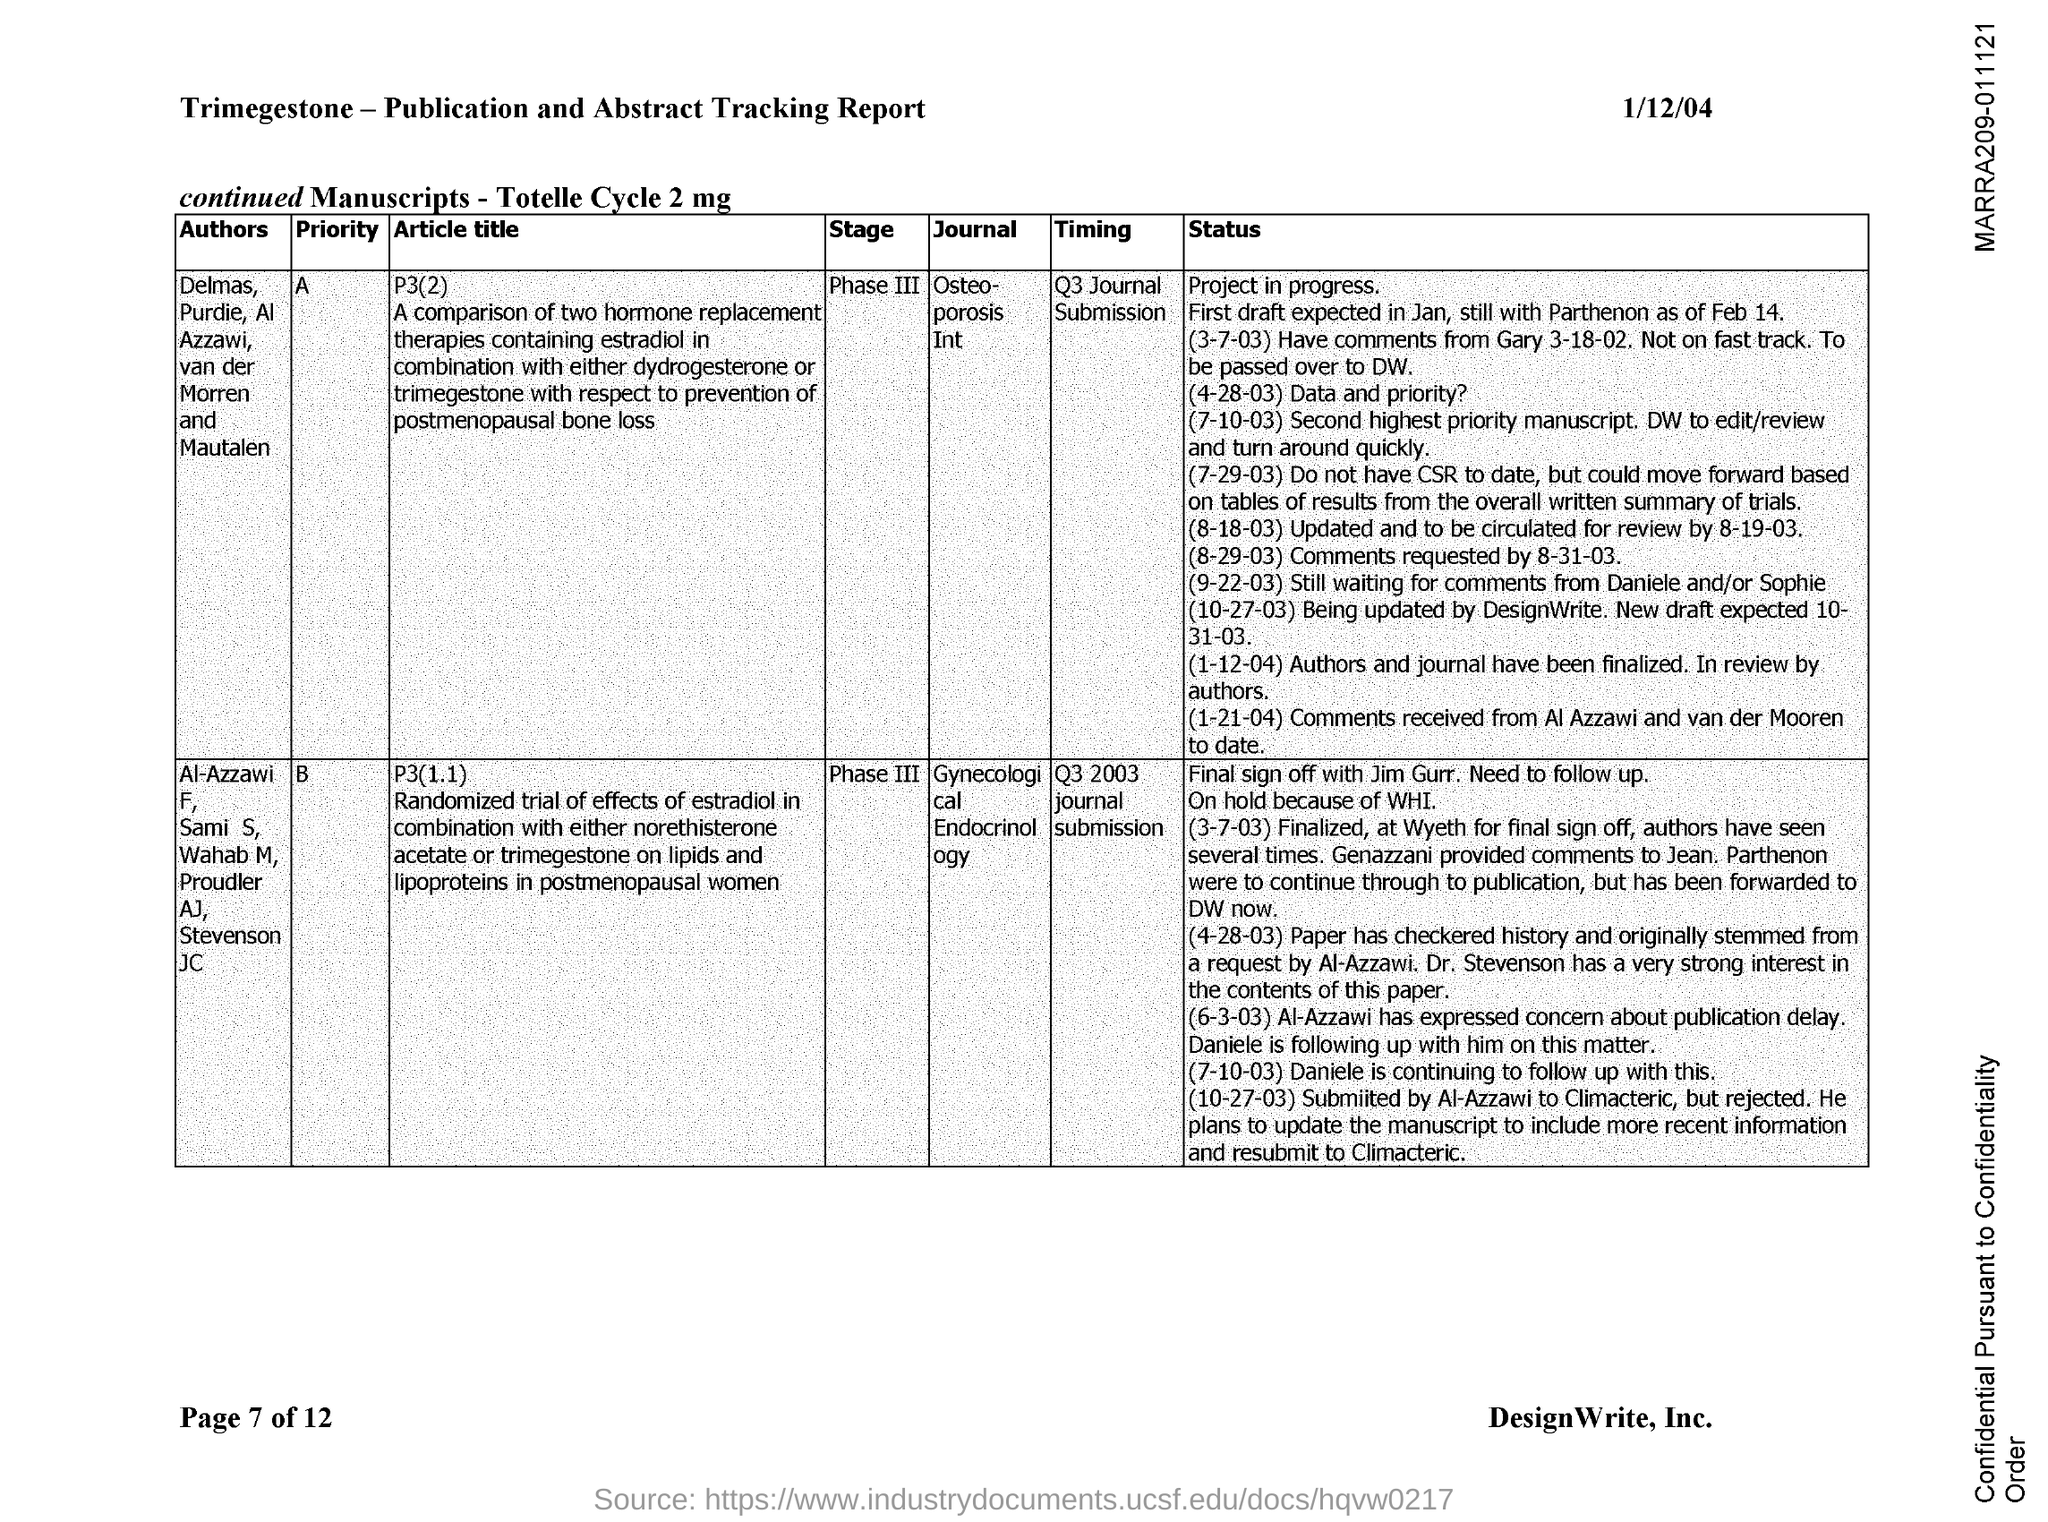What is the date mentioned in the document?
Your answer should be very brief. 1/12/04. What is the name of the journal with priority "A"?
Provide a short and direct response. Osteoporosis Int. What is the name of the journal with priority "B"?
Your response must be concise. Gynecological Endocrinology. What is the current stage of the journal with priority "A"?
Ensure brevity in your answer.  Phase III. What is the current stage of the journal with priority "B"?
Your answer should be very brief. Phase III. 